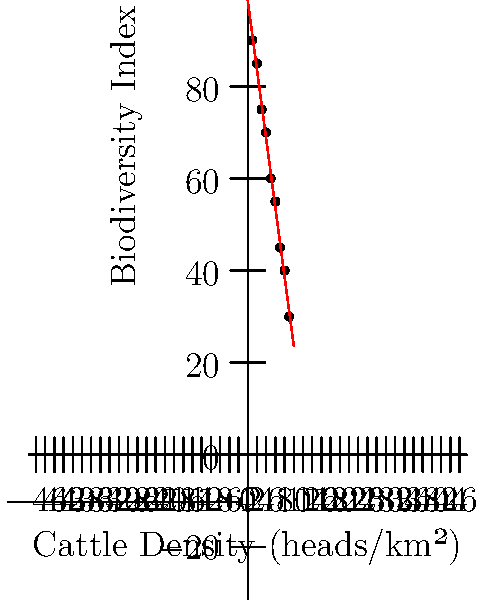Based on the linear regression model shown in the scatter plot, what is the predicted Biodiversity Index when the Cattle Density is 12 heads/km²? Round your answer to the nearest whole number. To solve this problem, we need to follow these steps:

1. Identify the equation of the linear regression line:
   The line is in the form $y = mx + b$, where $m$ is the slope and $b$ is the y-intercept.

2. Determine the slope ($m$) and y-intercept ($b$) from the graph:
   We can estimate these values by looking at two points on the line.
   Point 1: (0, 100)
   Point 2: (10, 20)

3. Calculate the slope:
   $m = \frac{y_2 - y_1}{x_2 - x_1} = \frac{20 - 100}{10 - 0} = -8$

4. Use the point-slope form to find the y-intercept:
   $y - y_1 = m(x - x_1)$
   $y - 100 = -8(x - 0)$
   $y = -8x + 100$

5. Now we have the equation of the line: $y = -8x + 100$

6. Plug in $x = 12$ (the given Cattle Density) to find $y$ (the Biodiversity Index):
   $y = -8(12) + 100 = -96 + 100 = 4$

7. Round to the nearest whole number: 4

Therefore, the predicted Biodiversity Index when the Cattle Density is 12 heads/km² is 4.
Answer: 4 